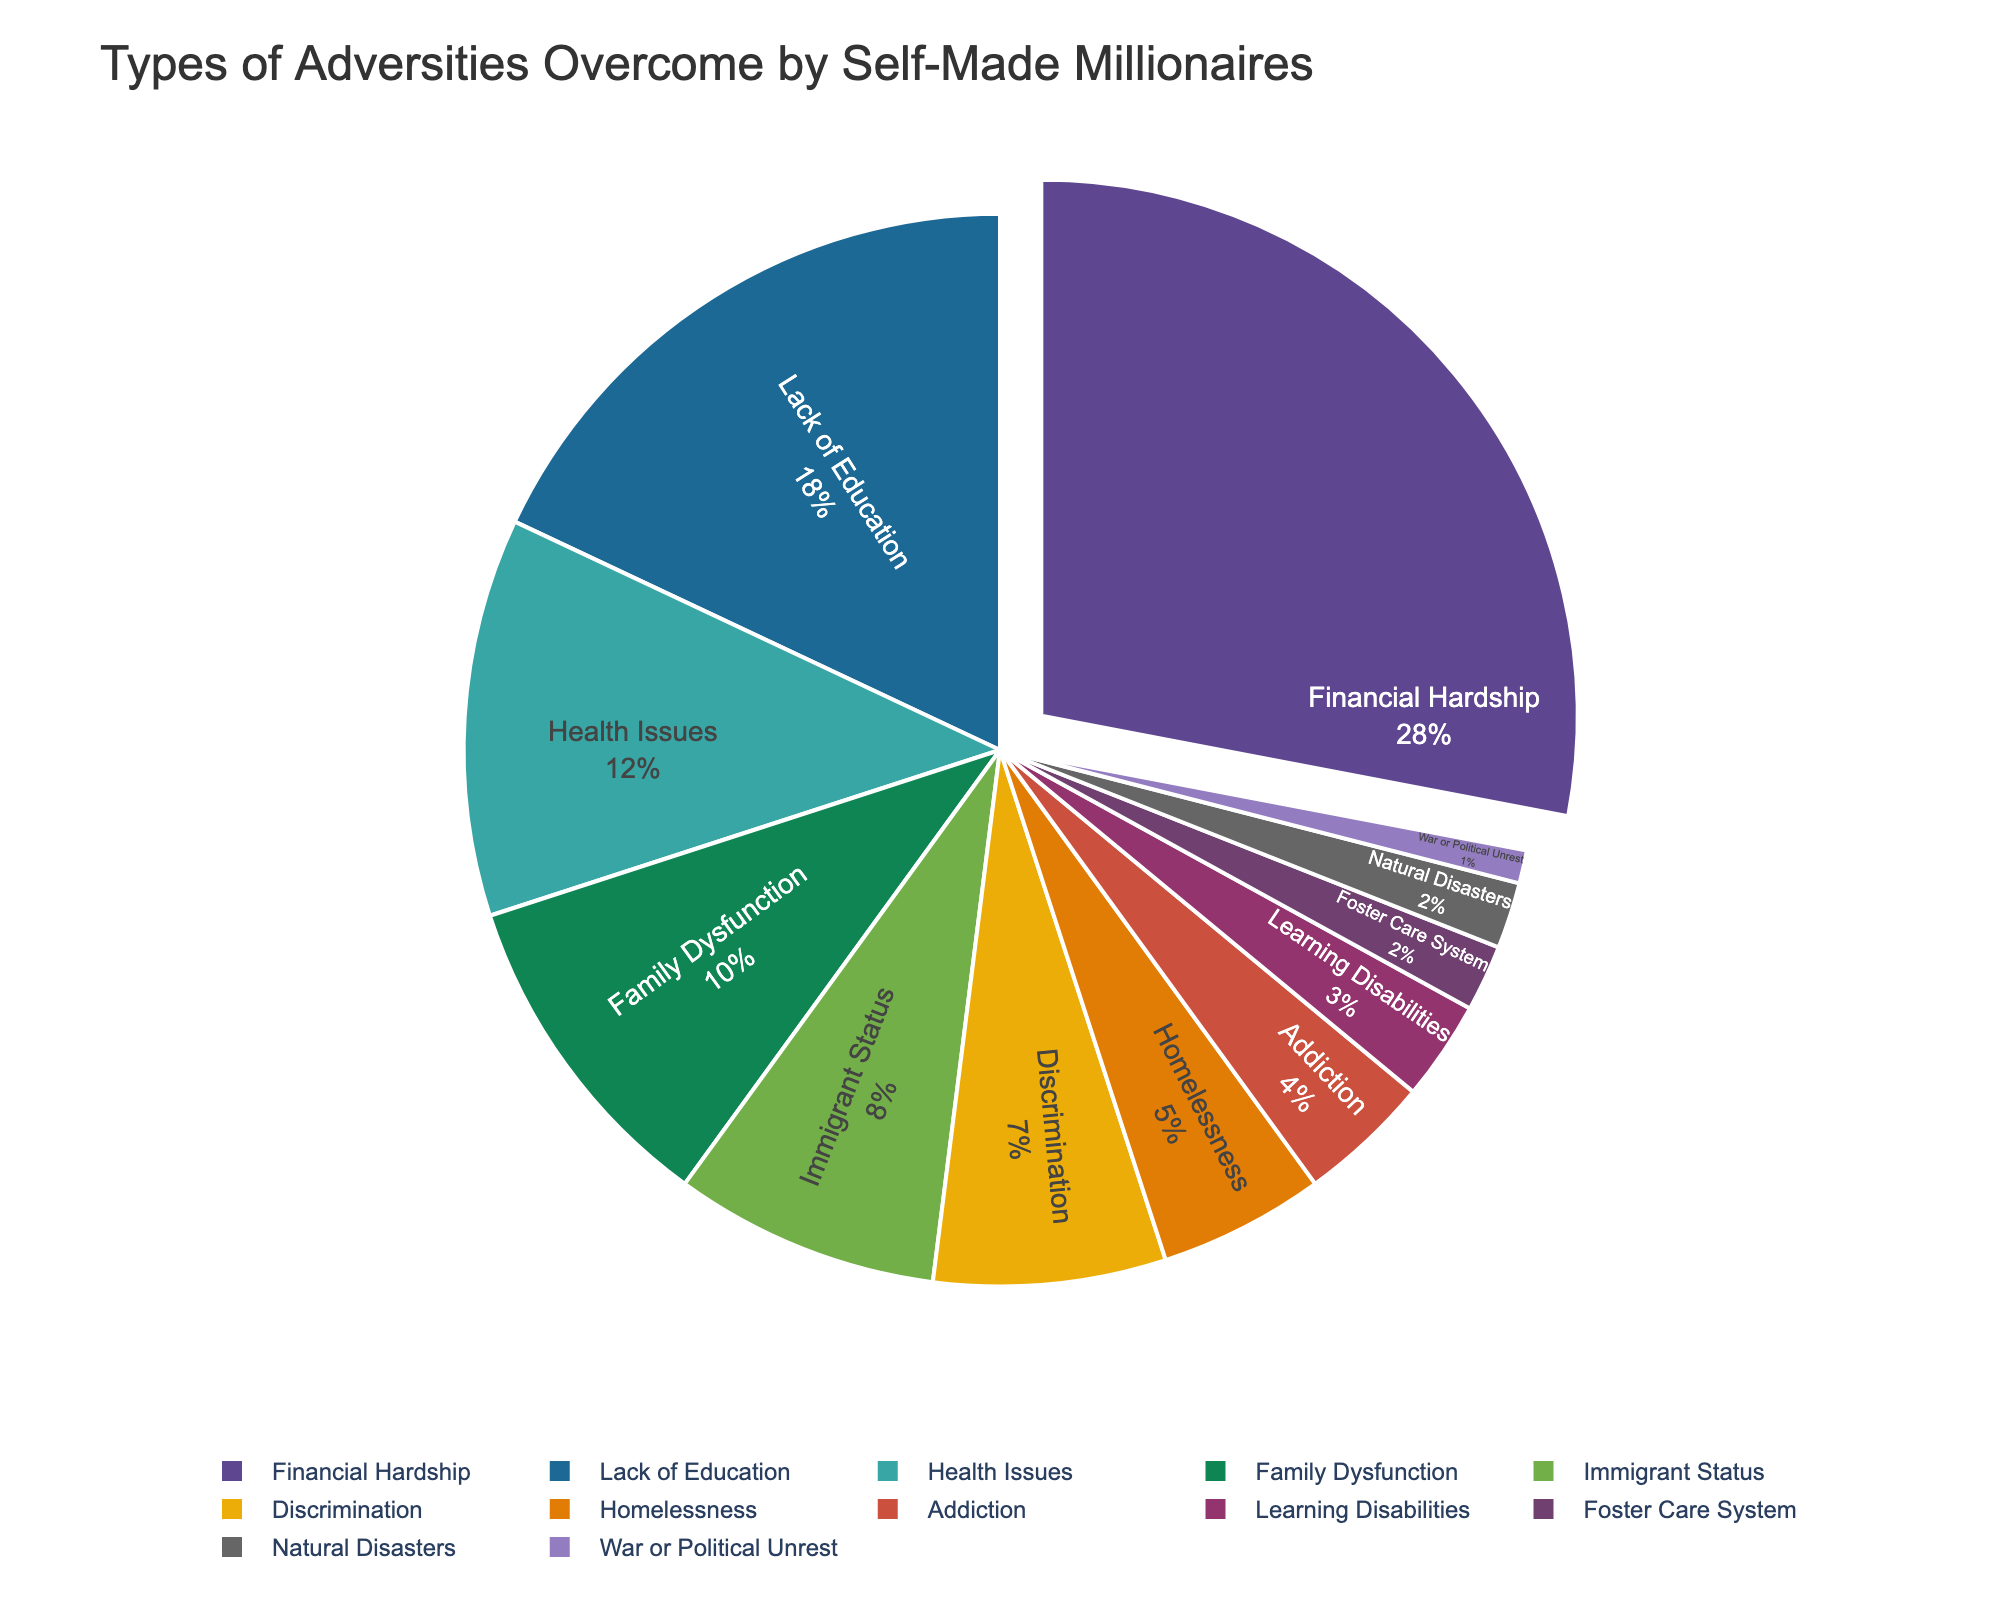Which type of adversity is the most common among self-made millionaires? By looking at the pie chart, the largest section represents the most common adversity. In this case, the section labeled "Financial Hardship" is the largest.
Answer: Financial Hardship How many types of adversities have a percentage lower than 5%? By examining the pie chart, you can count the sections with percentages under 5%. The adversities with less than 5% are Addiction, Learning Disabilities, Foster Care System, Natural Disasters, and War or Political Unrest, which totals to 5 types.
Answer: 5 What is the combined percentage of immigrants and those facing discrimination? Locate the sections for Immigrant Status (8%) and Discrimination (7%) in the pie chart and add their percentages together. 8% + 7% = 15%.
Answer: 15% How does the percentage of self-made millionaires who overcame health issues compare to those who faced family dysfunction? Compare the pie chart segments for Health Issues (12%) and Family Dysfunction (10%). Health Issues has a larger percentage.
Answer: Health Issues is greater Which type of adversity occupies a visually smaller segment: Learning Disabilities or Homelessness? Visual comparison of the pie chart segments shows that Learning Disabilities (3%) occupies a smaller segment than Homelessness (5%).
Answer: Learning Disabilities How many types of adversities have a percentage of 10% or higher? Count the segments marked with percentages that are 10% or higher: Financial Hardship (28%), Lack of Education (18%), Health Issues (12%), and Family Dysfunction (10%). This totals to 4 types.
Answer: 4 What is the difference in percentage between the most and least common adversities? Identify the most common adversity, Financial Hardship (28%), and the least common adversities, Natural Disasters and War or Political Unrest (both 1%). Subtract the lowest percentage from the highest: 28% - 1% = 27%.
Answer: 27% If you combine the percentages of those who overcame Financial Hardship, Lack of Education, and Health Issues, what percentage does it represent? Summing the percentages for Financial Hardship (28%), Lack of Education (18%), and Health Issues (12%) yields 28% + 18% + 12% = 58%.
Answer: 58% What proportion of pie chart segments are related to adversities experienced during childhood (e.g., family dysfunction, learning disabilities, foster care system)? Count the segments related to childhood adversities: Family Dysfunction (10%), Learning Disabilities (3%), and Foster Care System (2%). There are 3 such segments.
Answer: 3 